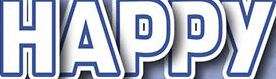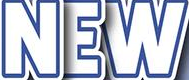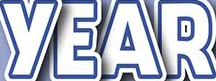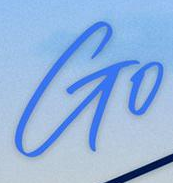Transcribe the words shown in these images in order, separated by a semicolon. HAPPY; NEW; YEAR; Go 